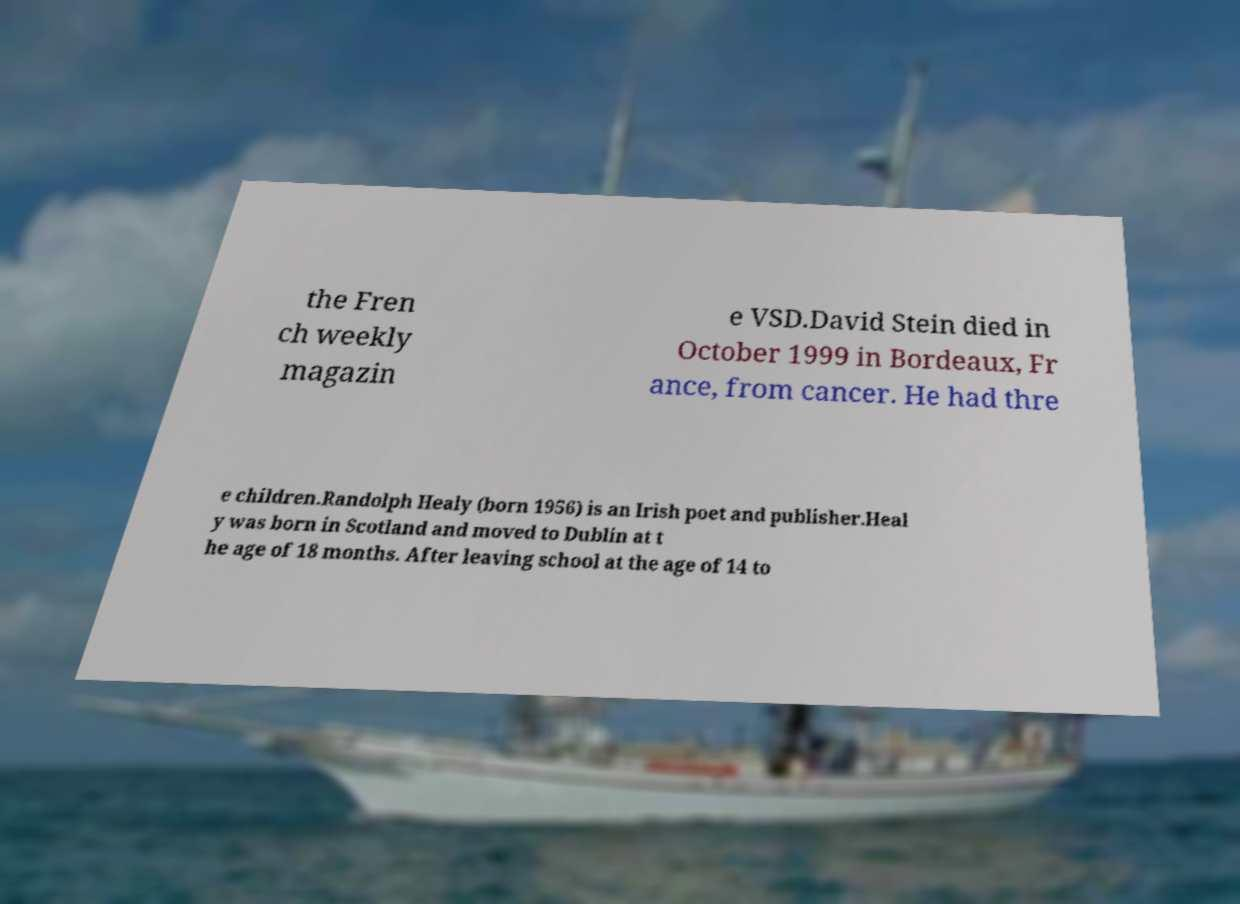Can you accurately transcribe the text from the provided image for me? the Fren ch weekly magazin e VSD.David Stein died in October 1999 in Bordeaux, Fr ance, from cancer. He had thre e children.Randolph Healy (born 1956) is an Irish poet and publisher.Heal y was born in Scotland and moved to Dublin at t he age of 18 months. After leaving school at the age of 14 to 